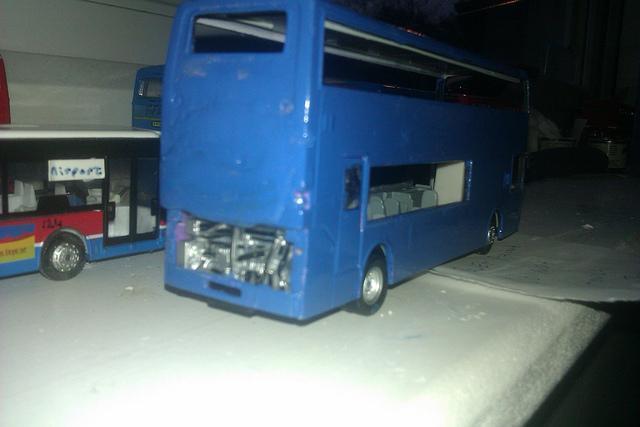How many buses are there?
Give a very brief answer. 2. How many vases do you see?
Give a very brief answer. 0. 